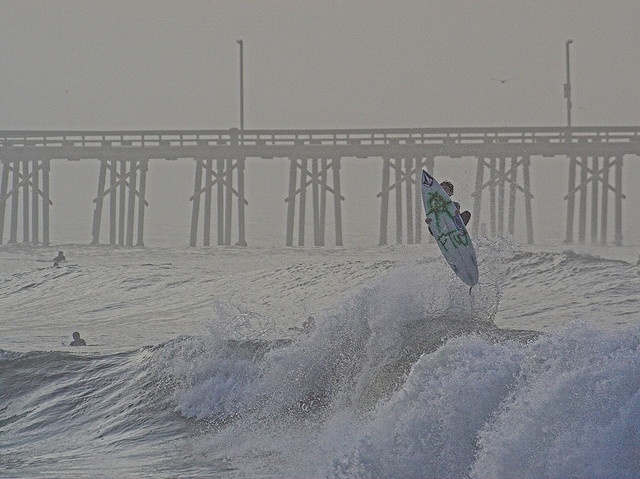Describe the objects in this image and their specific colors. I can see surfboard in gray, teal, and black tones, people in gray, black, and darkgray tones, people in gray and black tones, and people in gray and darkgray tones in this image. 